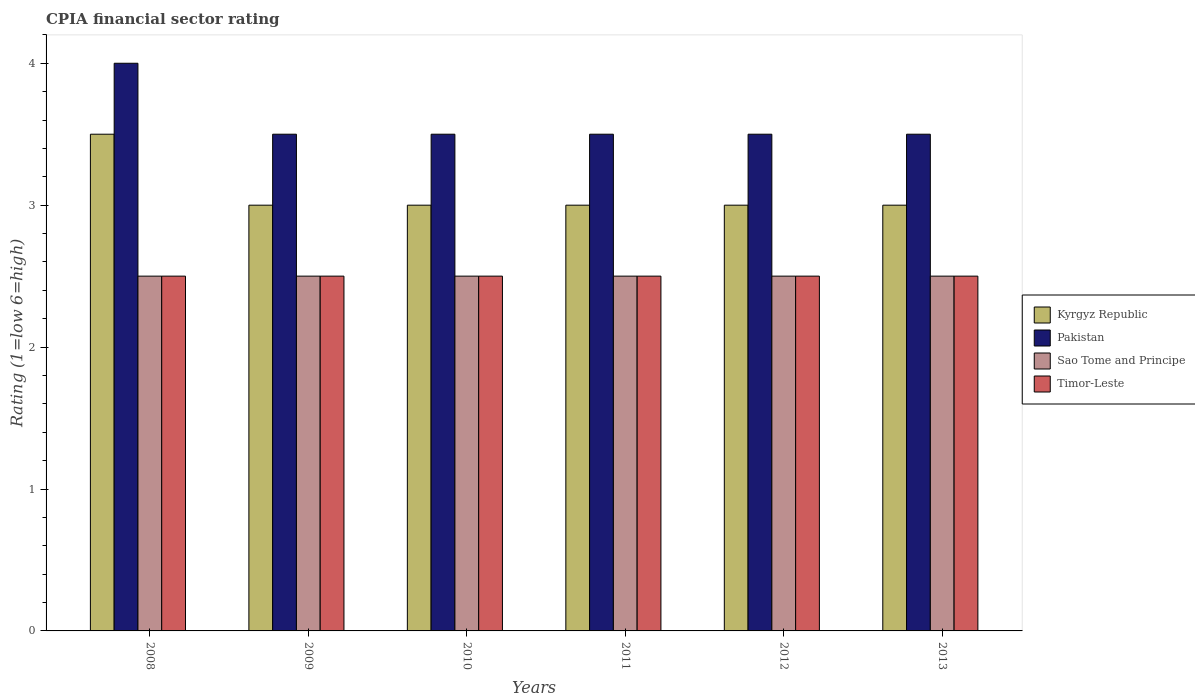How many different coloured bars are there?
Keep it short and to the point. 4. How many groups of bars are there?
Give a very brief answer. 6. How many bars are there on the 6th tick from the right?
Your response must be concise. 4. What is the CPIA rating in Timor-Leste in 2008?
Give a very brief answer. 2.5. In which year was the CPIA rating in Kyrgyz Republic maximum?
Keep it short and to the point. 2008. What is the difference between the CPIA rating in Sao Tome and Principe in 2011 and the CPIA rating in Pakistan in 2012?
Make the answer very short. -1. What is the average CPIA rating in Sao Tome and Principe per year?
Provide a short and direct response. 2.5. Is the CPIA rating in Kyrgyz Republic in 2011 less than that in 2012?
Make the answer very short. No. Is the sum of the CPIA rating in Sao Tome and Principe in 2010 and 2012 greater than the maximum CPIA rating in Kyrgyz Republic across all years?
Your response must be concise. Yes. Is it the case that in every year, the sum of the CPIA rating in Timor-Leste and CPIA rating in Pakistan is greater than the sum of CPIA rating in Sao Tome and Principe and CPIA rating in Kyrgyz Republic?
Ensure brevity in your answer.  Yes. What does the 3rd bar from the left in 2013 represents?
Your answer should be very brief. Sao Tome and Principe. Is it the case that in every year, the sum of the CPIA rating in Pakistan and CPIA rating in Timor-Leste is greater than the CPIA rating in Sao Tome and Principe?
Your answer should be compact. Yes. Are all the bars in the graph horizontal?
Your answer should be compact. No. What is the difference between two consecutive major ticks on the Y-axis?
Keep it short and to the point. 1. Does the graph contain any zero values?
Provide a short and direct response. No. How are the legend labels stacked?
Offer a very short reply. Vertical. What is the title of the graph?
Offer a very short reply. CPIA financial sector rating. What is the label or title of the X-axis?
Provide a short and direct response. Years. What is the label or title of the Y-axis?
Your response must be concise. Rating (1=low 6=high). What is the Rating (1=low 6=high) in Kyrgyz Republic in 2008?
Your response must be concise. 3.5. What is the Rating (1=low 6=high) of Sao Tome and Principe in 2008?
Provide a succinct answer. 2.5. What is the Rating (1=low 6=high) in Pakistan in 2009?
Give a very brief answer. 3.5. What is the Rating (1=low 6=high) in Sao Tome and Principe in 2009?
Ensure brevity in your answer.  2.5. What is the Rating (1=low 6=high) of Timor-Leste in 2009?
Offer a terse response. 2.5. What is the Rating (1=low 6=high) of Kyrgyz Republic in 2010?
Your answer should be very brief. 3. What is the Rating (1=low 6=high) of Pakistan in 2010?
Offer a terse response. 3.5. What is the Rating (1=low 6=high) in Timor-Leste in 2011?
Your answer should be compact. 2.5. What is the Rating (1=low 6=high) in Pakistan in 2012?
Keep it short and to the point. 3.5. What is the Rating (1=low 6=high) in Sao Tome and Principe in 2012?
Give a very brief answer. 2.5. What is the Rating (1=low 6=high) of Timor-Leste in 2012?
Offer a very short reply. 2.5. What is the Rating (1=low 6=high) in Kyrgyz Republic in 2013?
Offer a terse response. 3. Across all years, what is the maximum Rating (1=low 6=high) in Pakistan?
Your answer should be very brief. 4. What is the total Rating (1=low 6=high) of Pakistan in the graph?
Give a very brief answer. 21.5. What is the total Rating (1=low 6=high) of Sao Tome and Principe in the graph?
Make the answer very short. 15. What is the difference between the Rating (1=low 6=high) in Pakistan in 2008 and that in 2009?
Your answer should be compact. 0.5. What is the difference between the Rating (1=low 6=high) of Timor-Leste in 2008 and that in 2009?
Offer a very short reply. 0. What is the difference between the Rating (1=low 6=high) in Sao Tome and Principe in 2008 and that in 2010?
Give a very brief answer. 0. What is the difference between the Rating (1=low 6=high) in Kyrgyz Republic in 2008 and that in 2011?
Offer a very short reply. 0.5. What is the difference between the Rating (1=low 6=high) in Pakistan in 2008 and that in 2011?
Keep it short and to the point. 0.5. What is the difference between the Rating (1=low 6=high) of Sao Tome and Principe in 2008 and that in 2011?
Provide a short and direct response. 0. What is the difference between the Rating (1=low 6=high) in Kyrgyz Republic in 2008 and that in 2012?
Your answer should be compact. 0.5. What is the difference between the Rating (1=low 6=high) in Pakistan in 2008 and that in 2012?
Give a very brief answer. 0.5. What is the difference between the Rating (1=low 6=high) in Kyrgyz Republic in 2008 and that in 2013?
Provide a short and direct response. 0.5. What is the difference between the Rating (1=low 6=high) of Timor-Leste in 2008 and that in 2013?
Give a very brief answer. 0. What is the difference between the Rating (1=low 6=high) in Kyrgyz Republic in 2009 and that in 2010?
Your answer should be very brief. 0. What is the difference between the Rating (1=low 6=high) of Sao Tome and Principe in 2009 and that in 2010?
Keep it short and to the point. 0. What is the difference between the Rating (1=low 6=high) in Timor-Leste in 2009 and that in 2010?
Give a very brief answer. 0. What is the difference between the Rating (1=low 6=high) of Kyrgyz Republic in 2009 and that in 2011?
Provide a succinct answer. 0. What is the difference between the Rating (1=low 6=high) in Sao Tome and Principe in 2009 and that in 2011?
Provide a short and direct response. 0. What is the difference between the Rating (1=low 6=high) of Kyrgyz Republic in 2009 and that in 2012?
Provide a short and direct response. 0. What is the difference between the Rating (1=low 6=high) in Pakistan in 2009 and that in 2012?
Offer a very short reply. 0. What is the difference between the Rating (1=low 6=high) of Sao Tome and Principe in 2009 and that in 2012?
Provide a succinct answer. 0. What is the difference between the Rating (1=low 6=high) of Pakistan in 2009 and that in 2013?
Provide a short and direct response. 0. What is the difference between the Rating (1=low 6=high) in Sao Tome and Principe in 2009 and that in 2013?
Keep it short and to the point. 0. What is the difference between the Rating (1=low 6=high) of Timor-Leste in 2009 and that in 2013?
Your answer should be very brief. 0. What is the difference between the Rating (1=low 6=high) in Kyrgyz Republic in 2010 and that in 2011?
Provide a succinct answer. 0. What is the difference between the Rating (1=low 6=high) of Pakistan in 2010 and that in 2011?
Make the answer very short. 0. What is the difference between the Rating (1=low 6=high) of Pakistan in 2010 and that in 2012?
Offer a very short reply. 0. What is the difference between the Rating (1=low 6=high) in Sao Tome and Principe in 2010 and that in 2012?
Offer a very short reply. 0. What is the difference between the Rating (1=low 6=high) in Kyrgyz Republic in 2010 and that in 2013?
Ensure brevity in your answer.  0. What is the difference between the Rating (1=low 6=high) of Timor-Leste in 2010 and that in 2013?
Offer a very short reply. 0. What is the difference between the Rating (1=low 6=high) in Pakistan in 2011 and that in 2012?
Give a very brief answer. 0. What is the difference between the Rating (1=low 6=high) of Sao Tome and Principe in 2011 and that in 2012?
Provide a succinct answer. 0. What is the difference between the Rating (1=low 6=high) in Timor-Leste in 2011 and that in 2012?
Provide a short and direct response. 0. What is the difference between the Rating (1=low 6=high) of Kyrgyz Republic in 2011 and that in 2013?
Give a very brief answer. 0. What is the difference between the Rating (1=low 6=high) in Pakistan in 2011 and that in 2013?
Make the answer very short. 0. What is the difference between the Rating (1=low 6=high) in Timor-Leste in 2011 and that in 2013?
Ensure brevity in your answer.  0. What is the difference between the Rating (1=low 6=high) of Kyrgyz Republic in 2012 and that in 2013?
Provide a short and direct response. 0. What is the difference between the Rating (1=low 6=high) of Pakistan in 2012 and that in 2013?
Offer a terse response. 0. What is the difference between the Rating (1=low 6=high) in Timor-Leste in 2012 and that in 2013?
Your response must be concise. 0. What is the difference between the Rating (1=low 6=high) in Kyrgyz Republic in 2008 and the Rating (1=low 6=high) in Pakistan in 2009?
Provide a succinct answer. 0. What is the difference between the Rating (1=low 6=high) of Pakistan in 2008 and the Rating (1=low 6=high) of Timor-Leste in 2009?
Your answer should be very brief. 1.5. What is the difference between the Rating (1=low 6=high) in Kyrgyz Republic in 2008 and the Rating (1=low 6=high) in Pakistan in 2010?
Keep it short and to the point. 0. What is the difference between the Rating (1=low 6=high) of Kyrgyz Republic in 2008 and the Rating (1=low 6=high) of Sao Tome and Principe in 2010?
Provide a short and direct response. 1. What is the difference between the Rating (1=low 6=high) of Sao Tome and Principe in 2008 and the Rating (1=low 6=high) of Timor-Leste in 2010?
Offer a very short reply. 0. What is the difference between the Rating (1=low 6=high) in Kyrgyz Republic in 2008 and the Rating (1=low 6=high) in Pakistan in 2011?
Give a very brief answer. 0. What is the difference between the Rating (1=low 6=high) of Kyrgyz Republic in 2008 and the Rating (1=low 6=high) of Sao Tome and Principe in 2011?
Provide a succinct answer. 1. What is the difference between the Rating (1=low 6=high) in Kyrgyz Republic in 2008 and the Rating (1=low 6=high) in Timor-Leste in 2011?
Your answer should be very brief. 1. What is the difference between the Rating (1=low 6=high) in Pakistan in 2008 and the Rating (1=low 6=high) in Sao Tome and Principe in 2011?
Your response must be concise. 1.5. What is the difference between the Rating (1=low 6=high) of Pakistan in 2008 and the Rating (1=low 6=high) of Timor-Leste in 2011?
Provide a short and direct response. 1.5. What is the difference between the Rating (1=low 6=high) of Pakistan in 2008 and the Rating (1=low 6=high) of Timor-Leste in 2012?
Make the answer very short. 1.5. What is the difference between the Rating (1=low 6=high) in Sao Tome and Principe in 2008 and the Rating (1=low 6=high) in Timor-Leste in 2012?
Provide a short and direct response. 0. What is the difference between the Rating (1=low 6=high) of Kyrgyz Republic in 2008 and the Rating (1=low 6=high) of Sao Tome and Principe in 2013?
Your answer should be very brief. 1. What is the difference between the Rating (1=low 6=high) of Kyrgyz Republic in 2008 and the Rating (1=low 6=high) of Timor-Leste in 2013?
Your answer should be compact. 1. What is the difference between the Rating (1=low 6=high) in Sao Tome and Principe in 2008 and the Rating (1=low 6=high) in Timor-Leste in 2013?
Give a very brief answer. 0. What is the difference between the Rating (1=low 6=high) of Kyrgyz Republic in 2009 and the Rating (1=low 6=high) of Pakistan in 2010?
Offer a very short reply. -0.5. What is the difference between the Rating (1=low 6=high) of Kyrgyz Republic in 2009 and the Rating (1=low 6=high) of Sao Tome and Principe in 2010?
Your response must be concise. 0.5. What is the difference between the Rating (1=low 6=high) of Kyrgyz Republic in 2009 and the Rating (1=low 6=high) of Timor-Leste in 2010?
Your response must be concise. 0.5. What is the difference between the Rating (1=low 6=high) of Pakistan in 2009 and the Rating (1=low 6=high) of Timor-Leste in 2010?
Your answer should be compact. 1. What is the difference between the Rating (1=low 6=high) of Kyrgyz Republic in 2009 and the Rating (1=low 6=high) of Timor-Leste in 2011?
Your answer should be compact. 0.5. What is the difference between the Rating (1=low 6=high) of Pakistan in 2009 and the Rating (1=low 6=high) of Timor-Leste in 2011?
Your answer should be compact. 1. What is the difference between the Rating (1=low 6=high) in Kyrgyz Republic in 2009 and the Rating (1=low 6=high) in Pakistan in 2012?
Keep it short and to the point. -0.5. What is the difference between the Rating (1=low 6=high) of Kyrgyz Republic in 2009 and the Rating (1=low 6=high) of Sao Tome and Principe in 2012?
Your response must be concise. 0.5. What is the difference between the Rating (1=low 6=high) in Kyrgyz Republic in 2009 and the Rating (1=low 6=high) in Timor-Leste in 2012?
Offer a terse response. 0.5. What is the difference between the Rating (1=low 6=high) in Pakistan in 2009 and the Rating (1=low 6=high) in Sao Tome and Principe in 2012?
Provide a succinct answer. 1. What is the difference between the Rating (1=low 6=high) of Kyrgyz Republic in 2009 and the Rating (1=low 6=high) of Pakistan in 2013?
Your answer should be very brief. -0.5. What is the difference between the Rating (1=low 6=high) of Kyrgyz Republic in 2009 and the Rating (1=low 6=high) of Sao Tome and Principe in 2013?
Offer a very short reply. 0.5. What is the difference between the Rating (1=low 6=high) in Kyrgyz Republic in 2009 and the Rating (1=low 6=high) in Timor-Leste in 2013?
Give a very brief answer. 0.5. What is the difference between the Rating (1=low 6=high) of Sao Tome and Principe in 2010 and the Rating (1=low 6=high) of Timor-Leste in 2011?
Provide a succinct answer. 0. What is the difference between the Rating (1=low 6=high) of Kyrgyz Republic in 2010 and the Rating (1=low 6=high) of Sao Tome and Principe in 2012?
Offer a very short reply. 0.5. What is the difference between the Rating (1=low 6=high) in Kyrgyz Republic in 2010 and the Rating (1=low 6=high) in Timor-Leste in 2012?
Your response must be concise. 0.5. What is the difference between the Rating (1=low 6=high) of Pakistan in 2010 and the Rating (1=low 6=high) of Timor-Leste in 2012?
Your answer should be very brief. 1. What is the difference between the Rating (1=low 6=high) in Kyrgyz Republic in 2010 and the Rating (1=low 6=high) in Pakistan in 2013?
Your answer should be very brief. -0.5. What is the difference between the Rating (1=low 6=high) in Pakistan in 2010 and the Rating (1=low 6=high) in Sao Tome and Principe in 2013?
Make the answer very short. 1. What is the difference between the Rating (1=low 6=high) in Kyrgyz Republic in 2011 and the Rating (1=low 6=high) in Sao Tome and Principe in 2012?
Make the answer very short. 0.5. What is the difference between the Rating (1=low 6=high) in Sao Tome and Principe in 2011 and the Rating (1=low 6=high) in Timor-Leste in 2012?
Ensure brevity in your answer.  0. What is the difference between the Rating (1=low 6=high) of Kyrgyz Republic in 2011 and the Rating (1=low 6=high) of Pakistan in 2013?
Provide a short and direct response. -0.5. What is the difference between the Rating (1=low 6=high) of Kyrgyz Republic in 2011 and the Rating (1=low 6=high) of Sao Tome and Principe in 2013?
Provide a succinct answer. 0.5. What is the difference between the Rating (1=low 6=high) in Kyrgyz Republic in 2011 and the Rating (1=low 6=high) in Timor-Leste in 2013?
Provide a short and direct response. 0.5. What is the difference between the Rating (1=low 6=high) in Sao Tome and Principe in 2011 and the Rating (1=low 6=high) in Timor-Leste in 2013?
Give a very brief answer. 0. What is the difference between the Rating (1=low 6=high) in Kyrgyz Republic in 2012 and the Rating (1=low 6=high) in Timor-Leste in 2013?
Give a very brief answer. 0.5. What is the difference between the Rating (1=low 6=high) in Pakistan in 2012 and the Rating (1=low 6=high) in Sao Tome and Principe in 2013?
Make the answer very short. 1. What is the average Rating (1=low 6=high) in Kyrgyz Republic per year?
Offer a terse response. 3.08. What is the average Rating (1=low 6=high) of Pakistan per year?
Offer a terse response. 3.58. In the year 2008, what is the difference between the Rating (1=low 6=high) of Kyrgyz Republic and Rating (1=low 6=high) of Pakistan?
Make the answer very short. -0.5. In the year 2008, what is the difference between the Rating (1=low 6=high) of Kyrgyz Republic and Rating (1=low 6=high) of Timor-Leste?
Provide a succinct answer. 1. In the year 2008, what is the difference between the Rating (1=low 6=high) of Pakistan and Rating (1=low 6=high) of Sao Tome and Principe?
Offer a terse response. 1.5. In the year 2008, what is the difference between the Rating (1=low 6=high) in Pakistan and Rating (1=low 6=high) in Timor-Leste?
Keep it short and to the point. 1.5. In the year 2008, what is the difference between the Rating (1=low 6=high) in Sao Tome and Principe and Rating (1=low 6=high) in Timor-Leste?
Keep it short and to the point. 0. In the year 2009, what is the difference between the Rating (1=low 6=high) in Pakistan and Rating (1=low 6=high) in Timor-Leste?
Provide a short and direct response. 1. In the year 2010, what is the difference between the Rating (1=low 6=high) in Kyrgyz Republic and Rating (1=low 6=high) in Sao Tome and Principe?
Give a very brief answer. 0.5. In the year 2010, what is the difference between the Rating (1=low 6=high) in Kyrgyz Republic and Rating (1=low 6=high) in Timor-Leste?
Keep it short and to the point. 0.5. In the year 2010, what is the difference between the Rating (1=low 6=high) in Pakistan and Rating (1=low 6=high) in Sao Tome and Principe?
Your response must be concise. 1. In the year 2011, what is the difference between the Rating (1=low 6=high) in Kyrgyz Republic and Rating (1=low 6=high) in Pakistan?
Your answer should be very brief. -0.5. In the year 2011, what is the difference between the Rating (1=low 6=high) of Kyrgyz Republic and Rating (1=low 6=high) of Timor-Leste?
Ensure brevity in your answer.  0.5. In the year 2011, what is the difference between the Rating (1=low 6=high) of Pakistan and Rating (1=low 6=high) of Timor-Leste?
Your response must be concise. 1. In the year 2011, what is the difference between the Rating (1=low 6=high) of Sao Tome and Principe and Rating (1=low 6=high) of Timor-Leste?
Give a very brief answer. 0. In the year 2012, what is the difference between the Rating (1=low 6=high) of Kyrgyz Republic and Rating (1=low 6=high) of Timor-Leste?
Ensure brevity in your answer.  0.5. In the year 2013, what is the difference between the Rating (1=low 6=high) in Kyrgyz Republic and Rating (1=low 6=high) in Pakistan?
Provide a succinct answer. -0.5. In the year 2013, what is the difference between the Rating (1=low 6=high) in Kyrgyz Republic and Rating (1=low 6=high) in Sao Tome and Principe?
Provide a short and direct response. 0.5. In the year 2013, what is the difference between the Rating (1=low 6=high) in Kyrgyz Republic and Rating (1=low 6=high) in Timor-Leste?
Provide a short and direct response. 0.5. In the year 2013, what is the difference between the Rating (1=low 6=high) of Pakistan and Rating (1=low 6=high) of Sao Tome and Principe?
Give a very brief answer. 1. What is the ratio of the Rating (1=low 6=high) in Pakistan in 2008 to that in 2010?
Your response must be concise. 1.14. What is the ratio of the Rating (1=low 6=high) in Timor-Leste in 2008 to that in 2010?
Offer a very short reply. 1. What is the ratio of the Rating (1=low 6=high) of Pakistan in 2008 to that in 2011?
Offer a very short reply. 1.14. What is the ratio of the Rating (1=low 6=high) of Kyrgyz Republic in 2008 to that in 2013?
Your response must be concise. 1.17. What is the ratio of the Rating (1=low 6=high) in Sao Tome and Principe in 2008 to that in 2013?
Your answer should be compact. 1. What is the ratio of the Rating (1=low 6=high) of Timor-Leste in 2008 to that in 2013?
Make the answer very short. 1. What is the ratio of the Rating (1=low 6=high) of Kyrgyz Republic in 2009 to that in 2010?
Your answer should be very brief. 1. What is the ratio of the Rating (1=low 6=high) of Sao Tome and Principe in 2009 to that in 2010?
Provide a short and direct response. 1. What is the ratio of the Rating (1=low 6=high) of Sao Tome and Principe in 2009 to that in 2011?
Offer a very short reply. 1. What is the ratio of the Rating (1=low 6=high) of Pakistan in 2009 to that in 2012?
Ensure brevity in your answer.  1. What is the ratio of the Rating (1=low 6=high) in Timor-Leste in 2009 to that in 2012?
Make the answer very short. 1. What is the ratio of the Rating (1=low 6=high) in Kyrgyz Republic in 2009 to that in 2013?
Provide a succinct answer. 1. What is the ratio of the Rating (1=low 6=high) in Sao Tome and Principe in 2009 to that in 2013?
Your response must be concise. 1. What is the ratio of the Rating (1=low 6=high) in Timor-Leste in 2009 to that in 2013?
Your answer should be very brief. 1. What is the ratio of the Rating (1=low 6=high) in Timor-Leste in 2010 to that in 2011?
Ensure brevity in your answer.  1. What is the ratio of the Rating (1=low 6=high) in Timor-Leste in 2010 to that in 2012?
Offer a terse response. 1. What is the ratio of the Rating (1=low 6=high) in Timor-Leste in 2010 to that in 2013?
Your answer should be very brief. 1. What is the ratio of the Rating (1=low 6=high) of Timor-Leste in 2011 to that in 2012?
Provide a succinct answer. 1. What is the ratio of the Rating (1=low 6=high) in Sao Tome and Principe in 2011 to that in 2013?
Provide a succinct answer. 1. What is the ratio of the Rating (1=low 6=high) of Kyrgyz Republic in 2012 to that in 2013?
Your answer should be very brief. 1. What is the ratio of the Rating (1=low 6=high) in Pakistan in 2012 to that in 2013?
Keep it short and to the point. 1. What is the difference between the highest and the second highest Rating (1=low 6=high) of Kyrgyz Republic?
Provide a succinct answer. 0.5. What is the difference between the highest and the second highest Rating (1=low 6=high) of Sao Tome and Principe?
Make the answer very short. 0. What is the difference between the highest and the second highest Rating (1=low 6=high) of Timor-Leste?
Provide a succinct answer. 0. What is the difference between the highest and the lowest Rating (1=low 6=high) in Kyrgyz Republic?
Your answer should be compact. 0.5. What is the difference between the highest and the lowest Rating (1=low 6=high) in Sao Tome and Principe?
Ensure brevity in your answer.  0. What is the difference between the highest and the lowest Rating (1=low 6=high) in Timor-Leste?
Your answer should be compact. 0. 